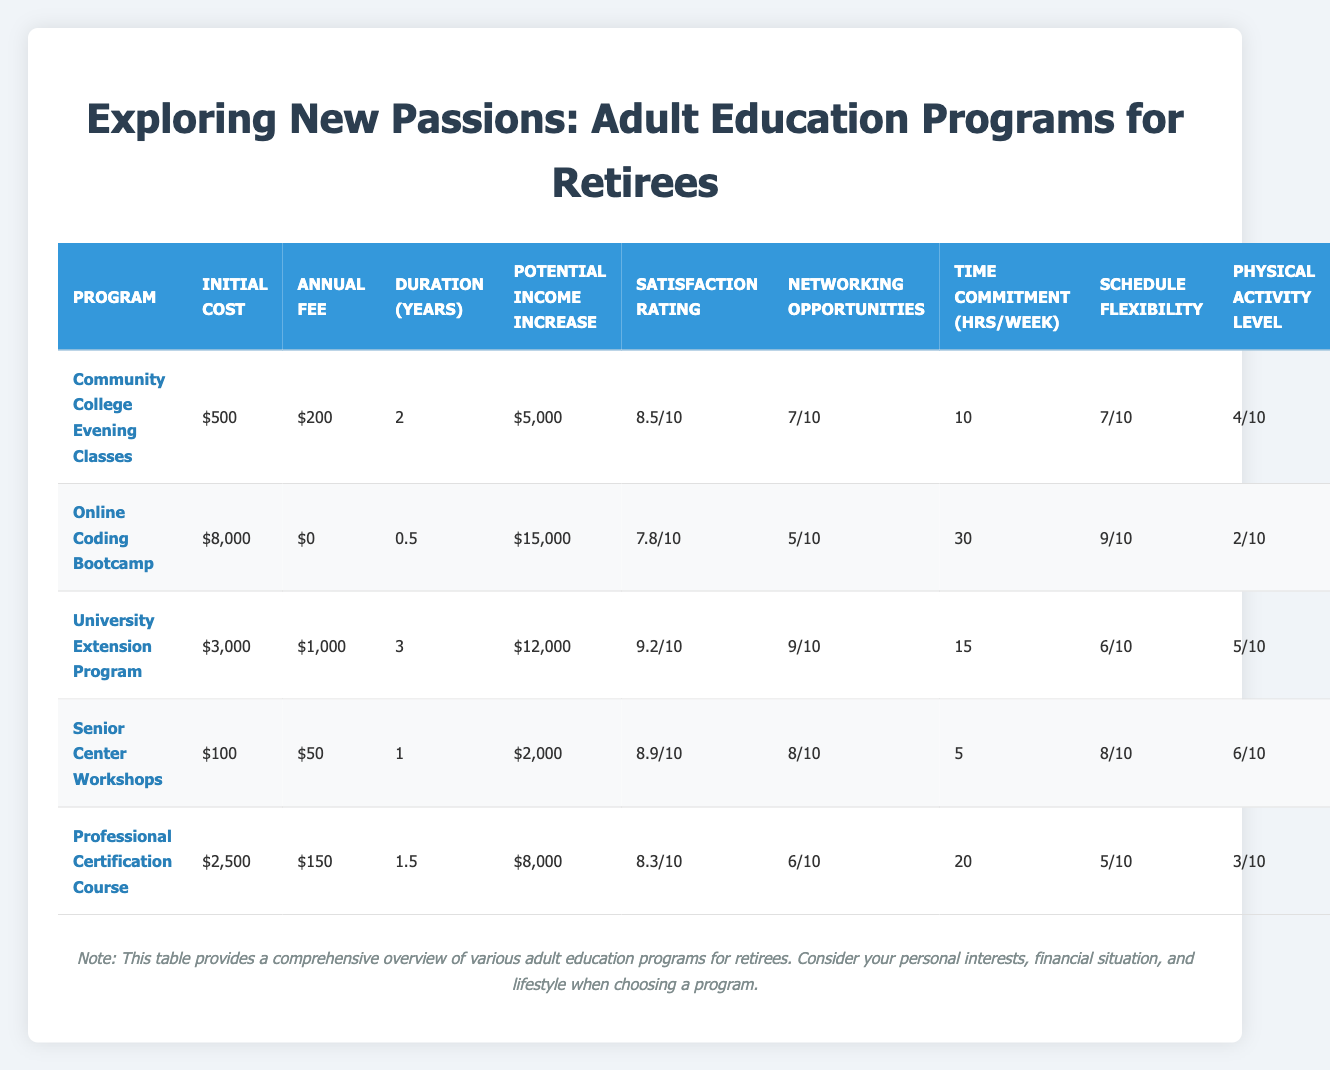What is the initial cost of the University Extension Program? The table lists the initial cost of each program under the "Initial Cost" column. For the University Extension Program, it is stated as $3,000.
Answer: $3,000 Which program has the highest potential income increase? To find this, I look at the "Potential Income Increase" column and compare the values. The Online Coding Bootcamp has the highest potential income increase of $15,000.
Answer: Online Coding Bootcamp Is the satisfaction rating of the Senior Center Workshops above 8? In the "Satisfaction Rating" column, the Senior Center Workshops have a rating of 8.9, which is indeed above 8.
Answer: Yes What is the average initial cost of all the programs? I add up the initial costs of all programs: 500 + 8000 + 3000 + 100 + 2500 = 10700. There are 5 programs, so the average is 10700 / 5 = 2140.
Answer: $2,140 How many programs have a physical activity level rating above 5? I review the "Physical Activity Level" column. The programs with ratings above 5 are University Extension Program (5), Senior Center Workshops (6), and no other programs meet this criterion. There are 2 programs.
Answer: 2 